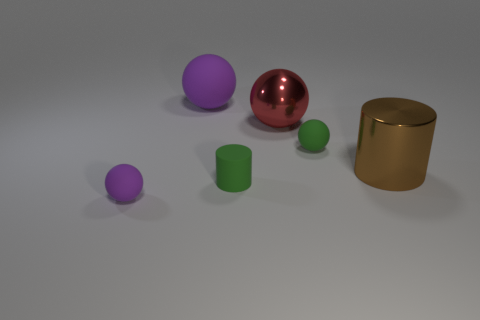Subtract all red spheres. How many spheres are left? 3 Subtract all brown cylinders. How many cylinders are left? 1 Subtract all yellow cubes. How many cyan cylinders are left? 0 Add 4 tiny purple matte things. How many objects exist? 10 Subtract all cylinders. How many objects are left? 4 Subtract 1 balls. How many balls are left? 3 Subtract all green spheres. Subtract all gray blocks. How many spheres are left? 3 Subtract all gray shiny cylinders. Subtract all red objects. How many objects are left? 5 Add 4 large metallic cylinders. How many large metallic cylinders are left? 5 Add 6 rubber spheres. How many rubber spheres exist? 9 